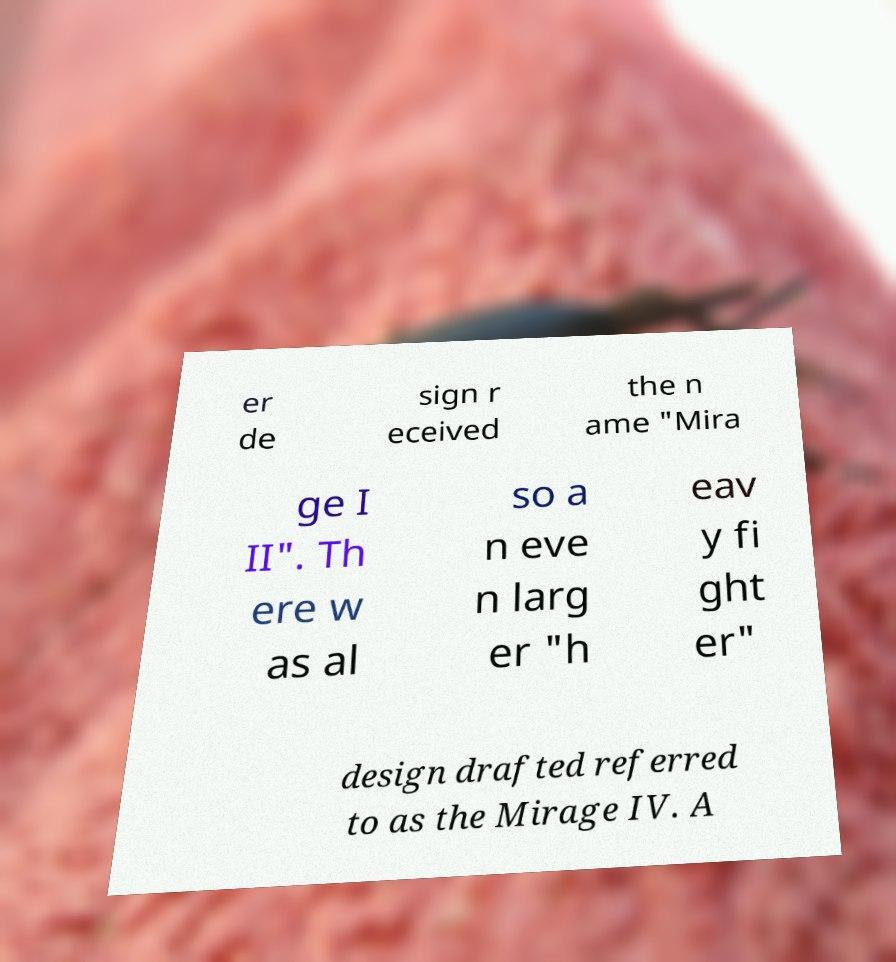What messages or text are displayed in this image? I need them in a readable, typed format. er de sign r eceived the n ame "Mira ge I II". Th ere w as al so a n eve n larg er "h eav y fi ght er" design drafted referred to as the Mirage IV. A 